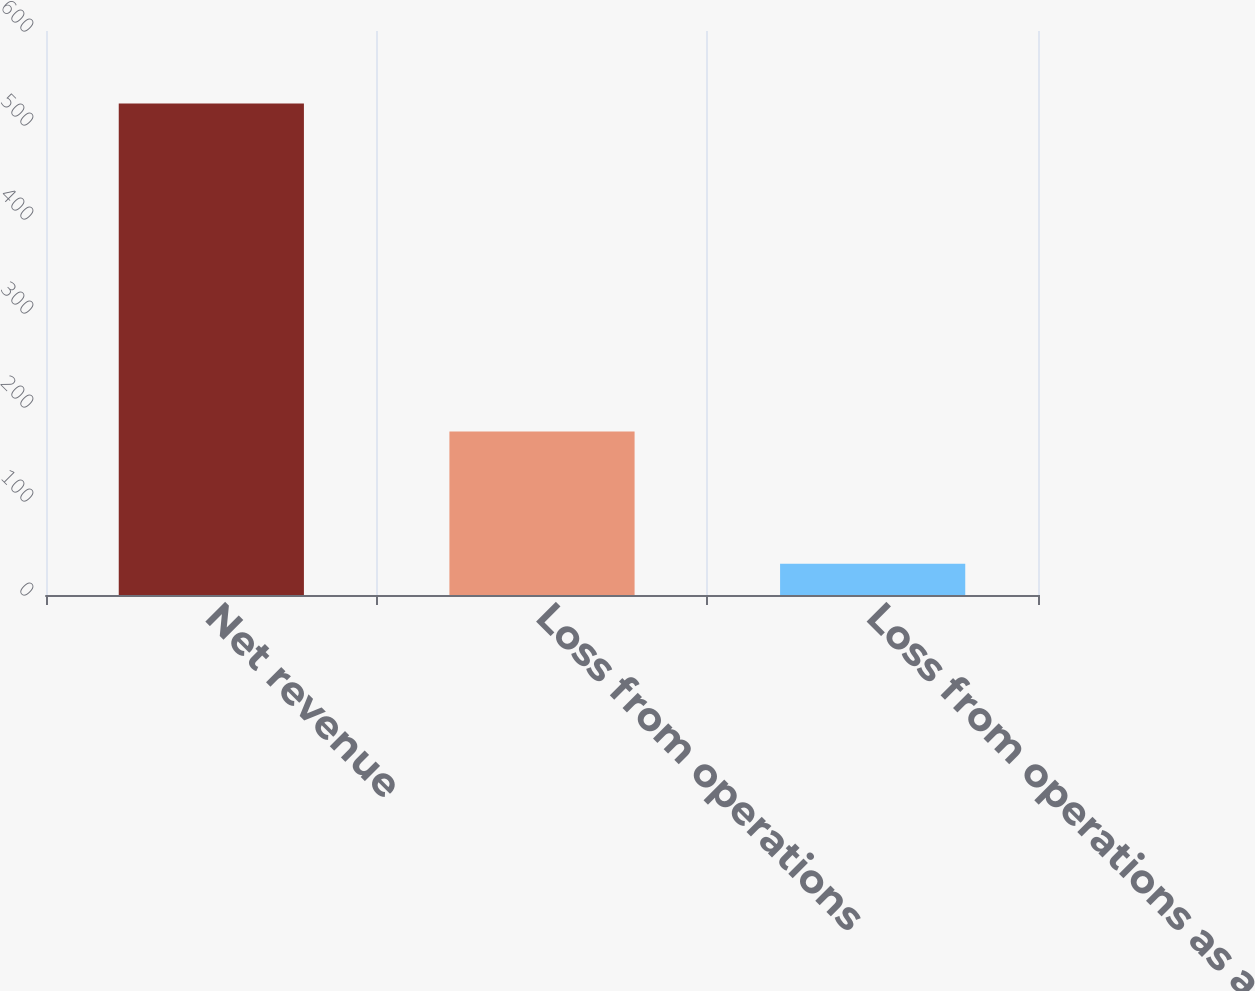Convert chart to OTSL. <chart><loc_0><loc_0><loc_500><loc_500><bar_chart><fcel>Net revenue<fcel>Loss from operations<fcel>Loss from operations as a of<nl><fcel>523<fcel>174<fcel>33.3<nl></chart> 